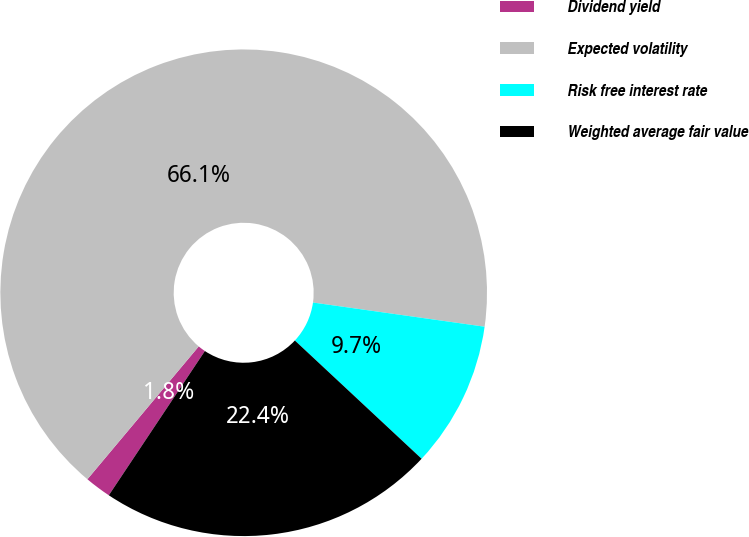<chart> <loc_0><loc_0><loc_500><loc_500><pie_chart><fcel>Dividend yield<fcel>Expected volatility<fcel>Risk free interest rate<fcel>Weighted average fair value<nl><fcel>1.75%<fcel>66.12%<fcel>9.72%<fcel>22.4%<nl></chart> 